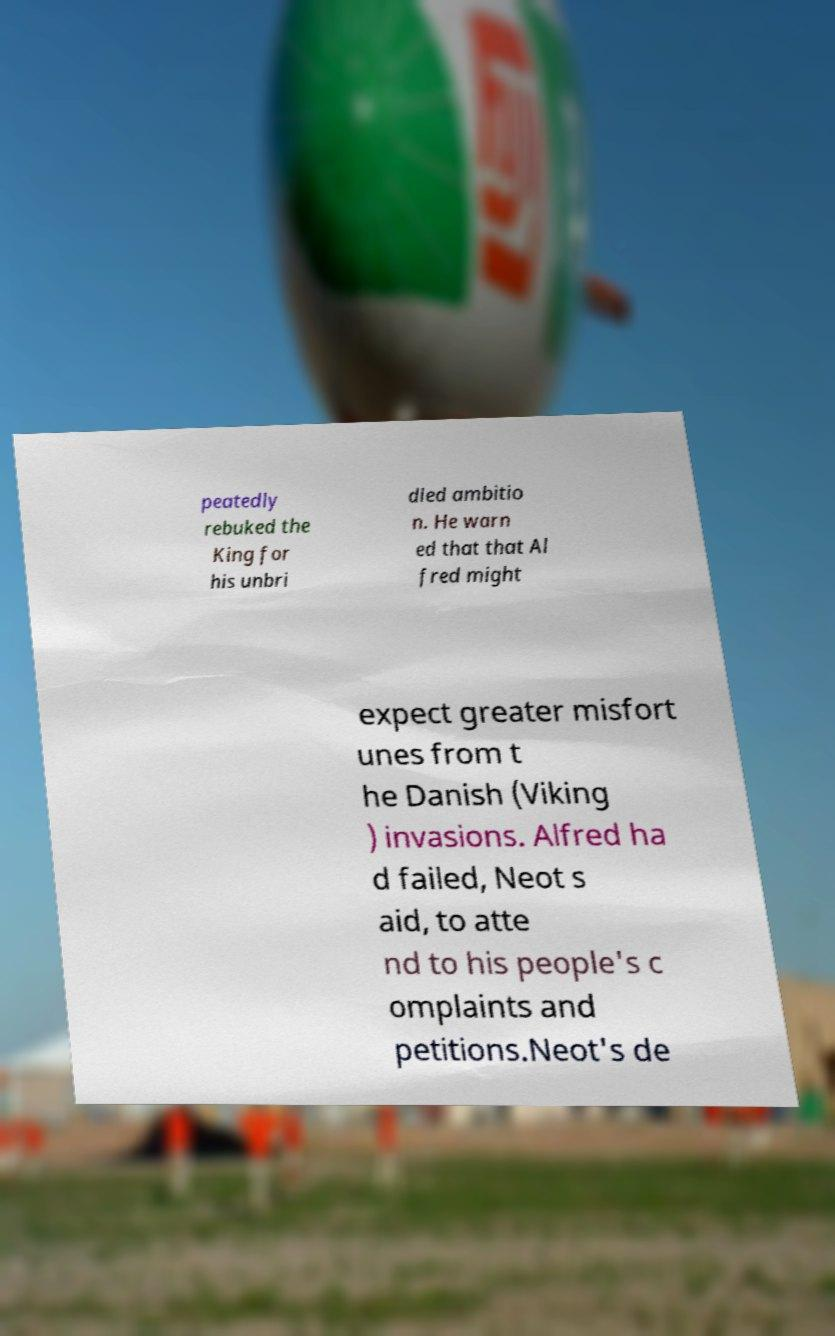Please read and relay the text visible in this image. What does it say? peatedly rebuked the King for his unbri dled ambitio n. He warn ed that that Al fred might expect greater misfort unes from t he Danish (Viking ) invasions. Alfred ha d failed, Neot s aid, to atte nd to his people's c omplaints and petitions.Neot's de 